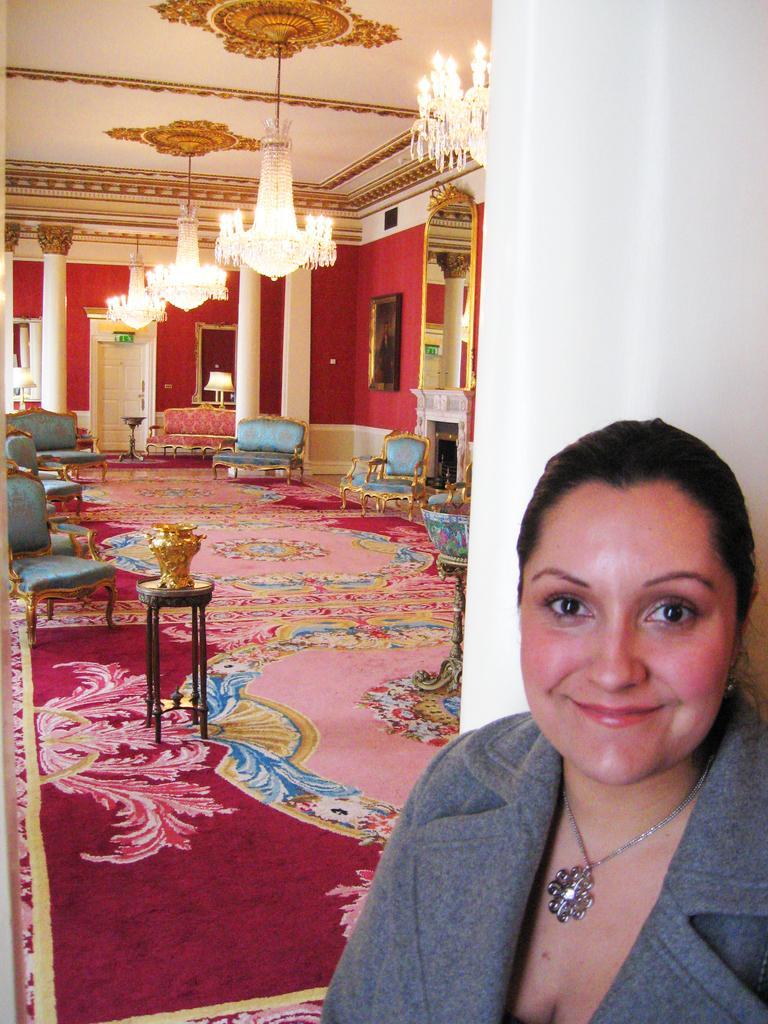Can you describe this image briefly? This woman is standing in-front of this pillar. This woman is smiling and wore jacket. A floor with carpet. In this room we can able to see pillars, lights are attached to roof top, couches, door, a picture on wall. On this table there is a vase. Far there is a lantern lamp. 